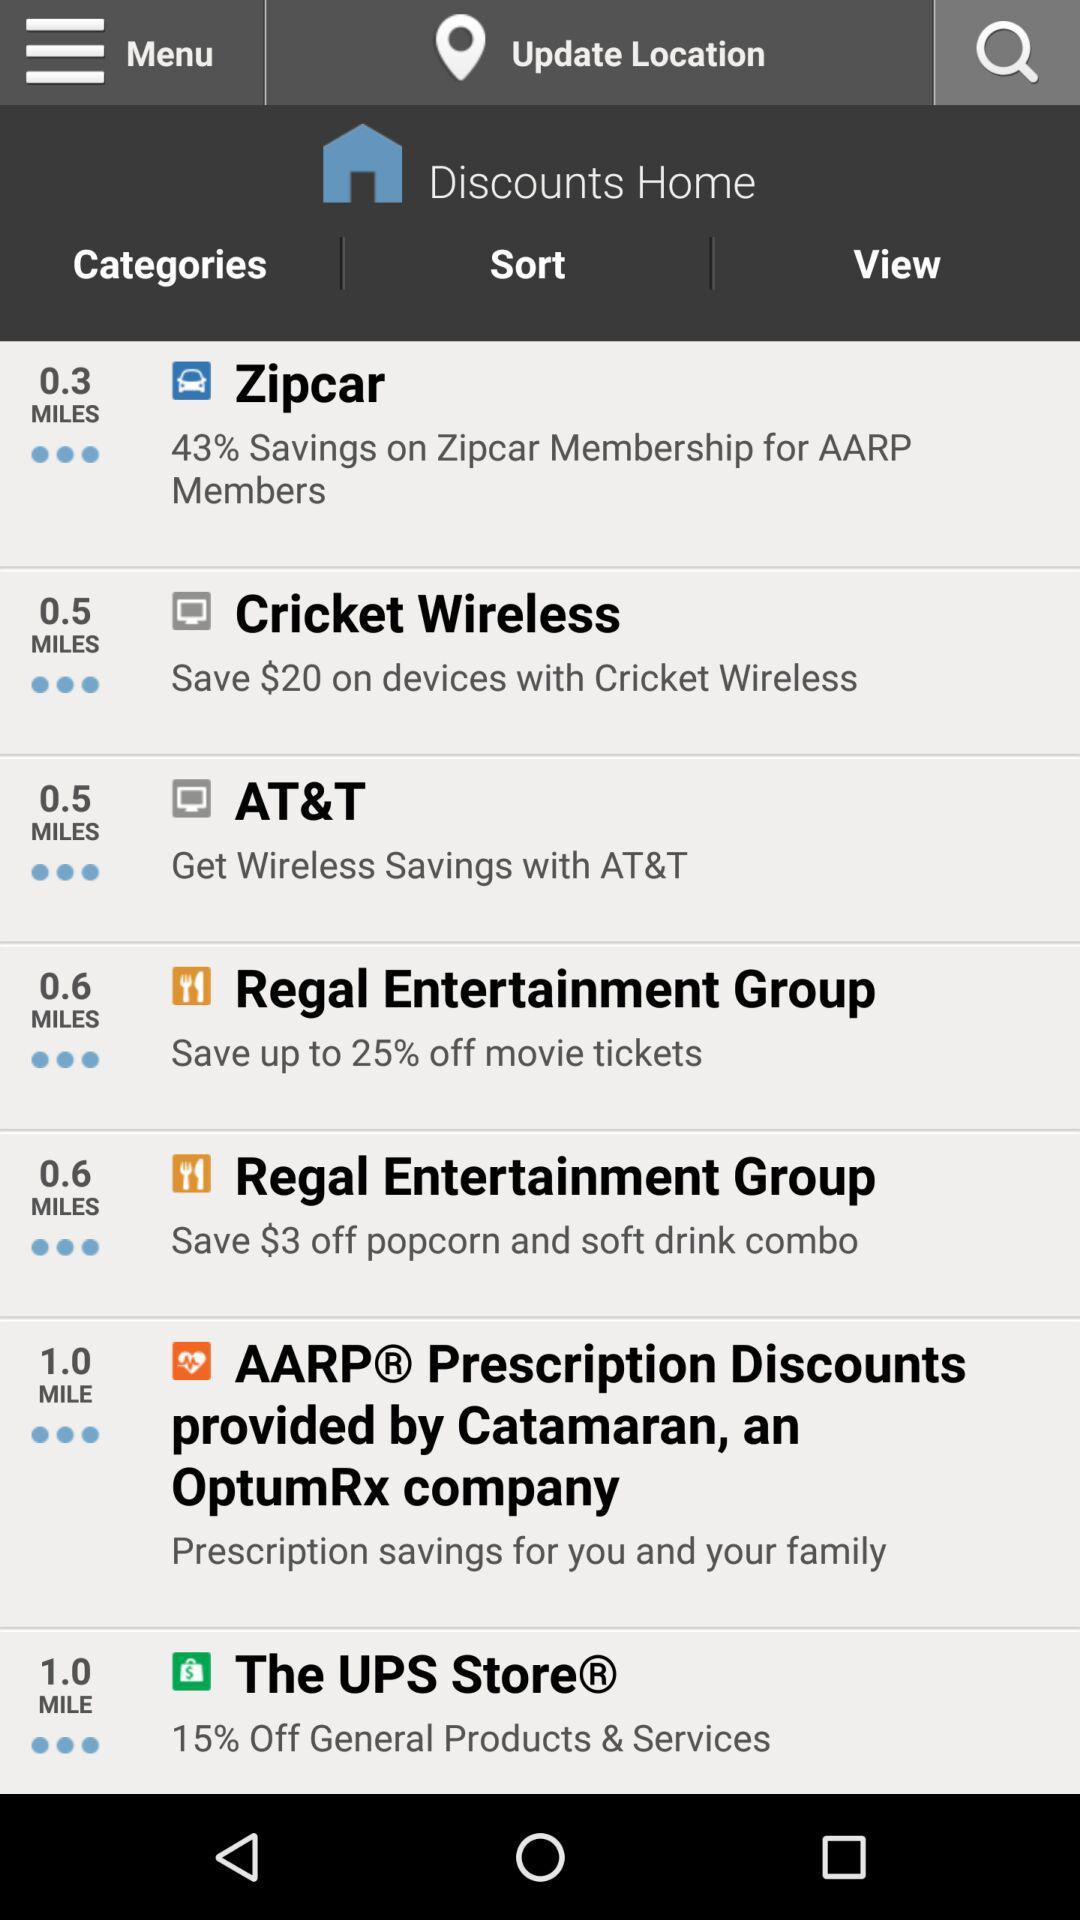How many dollars can we save on devices with "Cricket Wireless"? You can save $20 on devices with "Cricket Wireless". 